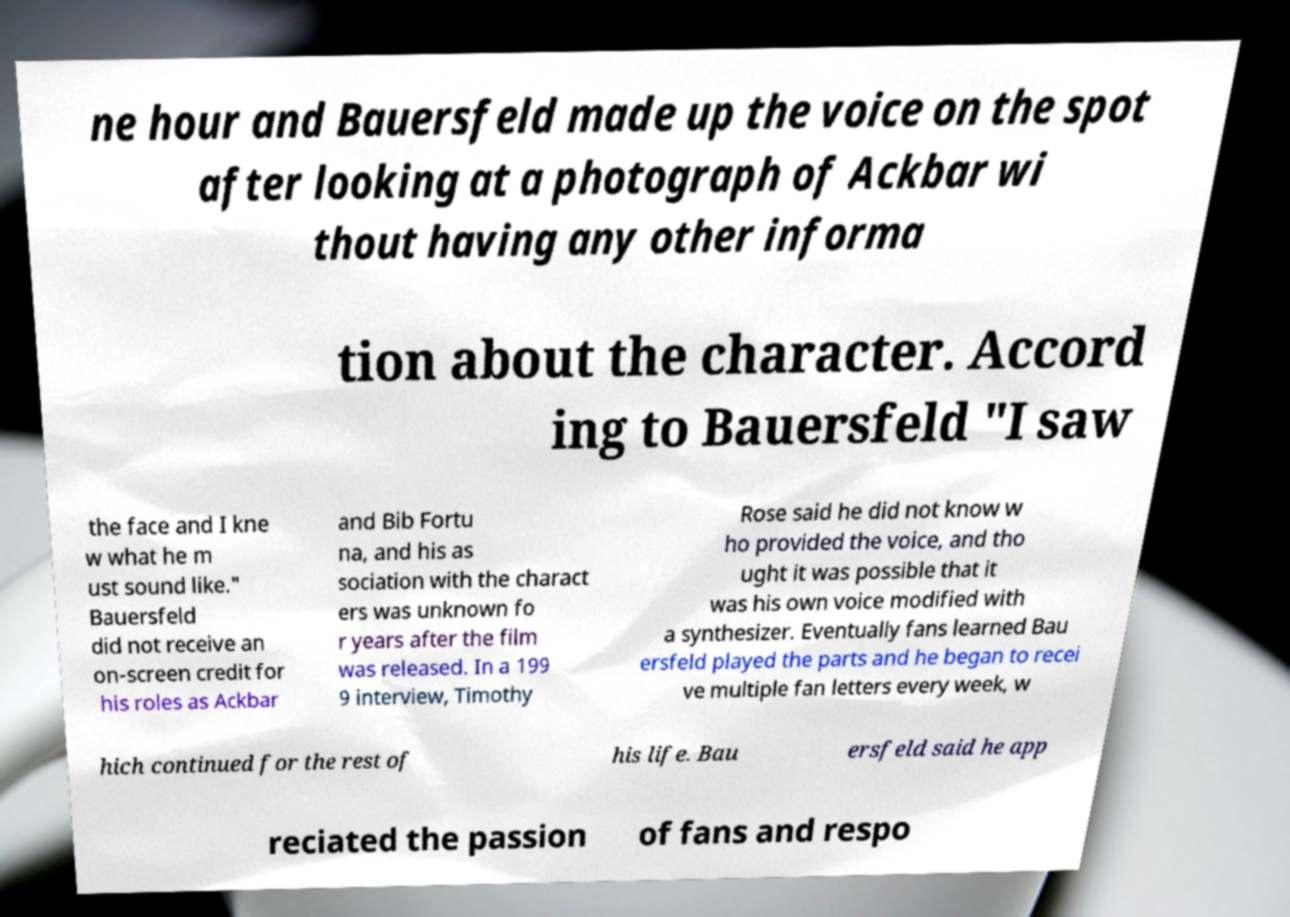I need the written content from this picture converted into text. Can you do that? ne hour and Bauersfeld made up the voice on the spot after looking at a photograph of Ackbar wi thout having any other informa tion about the character. Accord ing to Bauersfeld "I saw the face and I kne w what he m ust sound like." Bauersfeld did not receive an on-screen credit for his roles as Ackbar and Bib Fortu na, and his as sociation with the charact ers was unknown fo r years after the film was released. In a 199 9 interview, Timothy Rose said he did not know w ho provided the voice, and tho ught it was possible that it was his own voice modified with a synthesizer. Eventually fans learned Bau ersfeld played the parts and he began to recei ve multiple fan letters every week, w hich continued for the rest of his life. Bau ersfeld said he app reciated the passion of fans and respo 